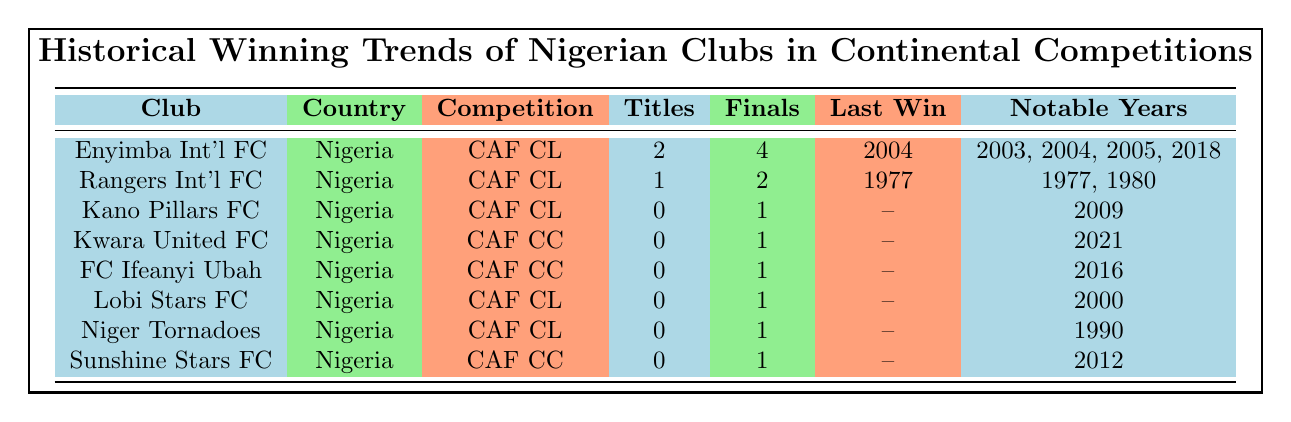What Nigerian club has the most titles in the CAF Champions League? Enyimba International FC has won 2 titles, which is the highest number among the Nigerian clubs listed in the table. Other clubs like Rangers International FC have only won 1 title.
Answer: Enyimba International FC Which club was the last to win a continental title? The last win for Enyimba International FC was in 2004, which is also the last win for any Nigerian club in the CAF Champions League. Other clubs listed did not have any recent title.
Answer: Enyimba International FC How many Nigerian clubs have appeared in the finals of the CAF Champions League? The table shows that 4 clubs, namely Enyimba International FC, Rangers International FC, Kano Pillars FC, and Lobi Stars FC, have appeared in the finals.
Answer: 4 clubs Did any Nigerian clubs win a title in the CAF Confederation Cup? No Nigerian club has won titles in the CAF Confederation Cup according to the table, as all listed clubs in this competition have 0 titles won.
Answer: No What is the total number of final appearances by Nigerian clubs in the CAF Champions League? Adding the final appearances: Enyimba International FC (4) + Rangers International FC (2) + Kano Pillars FC (1) + Lobi Stars FC (1) gives a total of 8 final appearances in the CAF Champions League.
Answer: 8 Which club has the earliest notable year listed? The earliest notable year is 1990 for Niger Tornadoes, as it is the first year mentioned in all notable years across the clubs.
Answer: Niger Tornadoes Which club has participated in the CAF Confederation Cup and had its last notable year in 2021? Kwara United FC participated in the CAF Confederation Cup, and its notable year is listed as 2021. This directly corresponds to the latest significant achievement they had in that competition.
Answer: Kwara United FC Is it true that all clubs in the table have participated in the CAF Champions League? No, it is false. The table indicates that some clubs like Kwara United FC and FC Ifeanyi Ubah participated in the CAF Confederation Cup, while others participated in the CAF Champions League.
Answer: False How many titles have the clubs combined won in continental competitions? The total number of titles won by the clubs is 3: 2 from Enyimba International FC and 1 from Rangers International FC, as the others have none.
Answer: 3 titles 